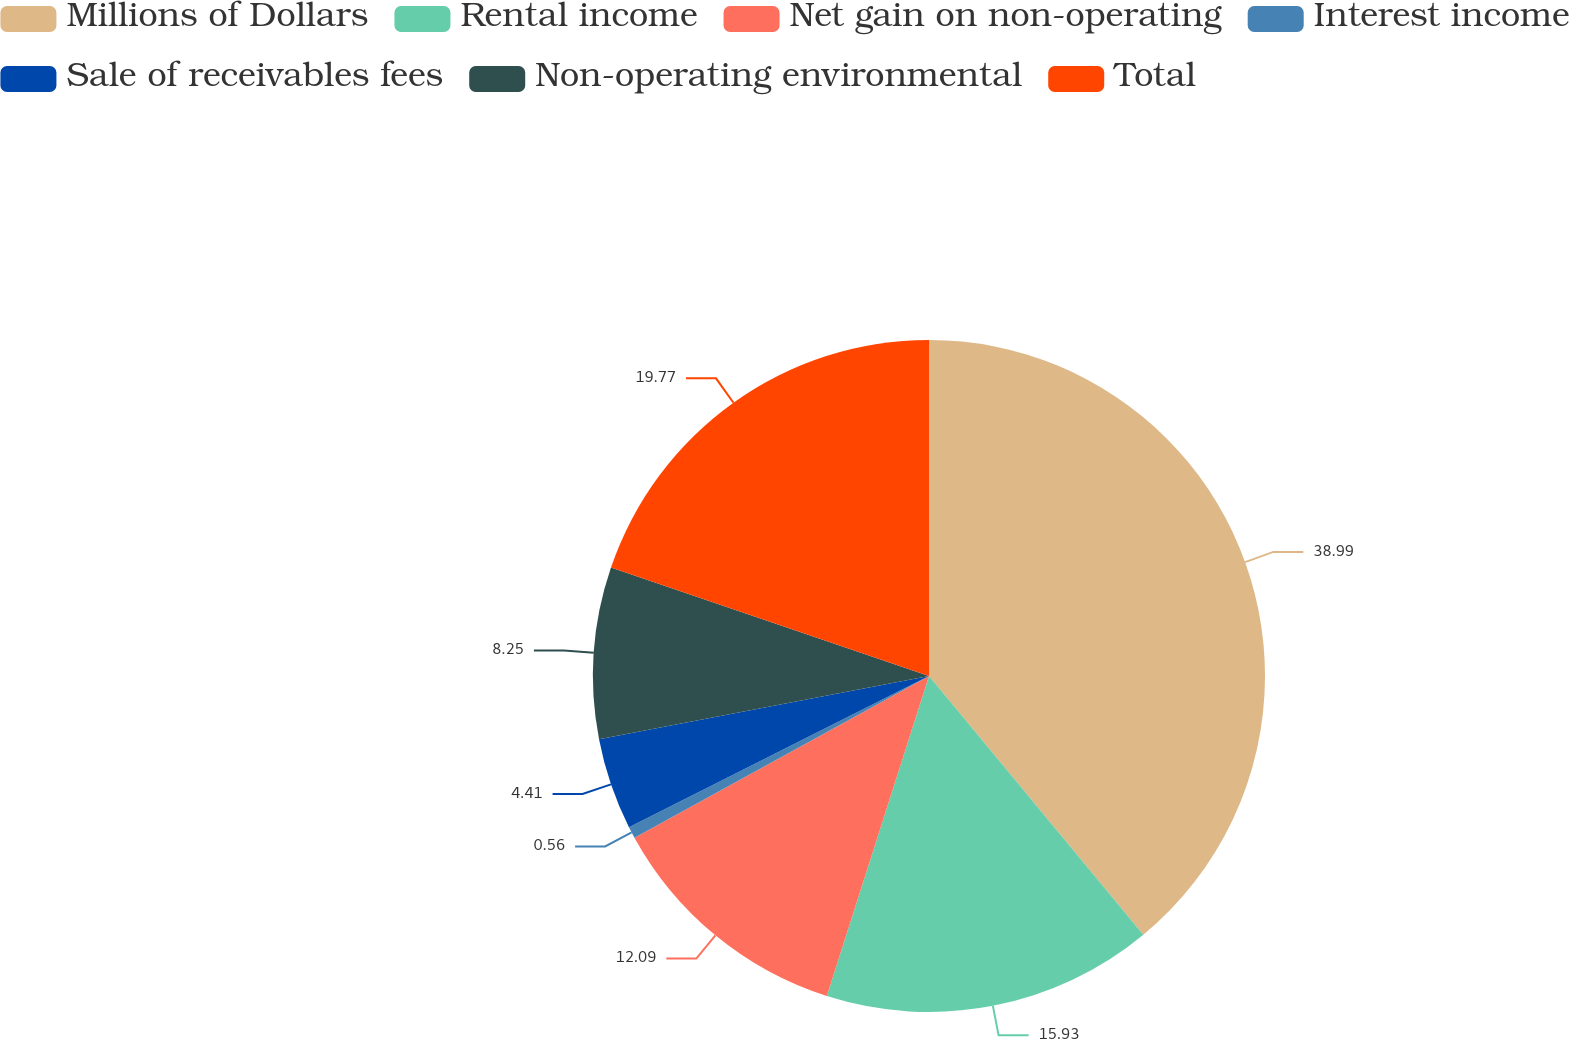<chart> <loc_0><loc_0><loc_500><loc_500><pie_chart><fcel>Millions of Dollars<fcel>Rental income<fcel>Net gain on non-operating<fcel>Interest income<fcel>Sale of receivables fees<fcel>Non-operating environmental<fcel>Total<nl><fcel>38.99%<fcel>15.93%<fcel>12.09%<fcel>0.56%<fcel>4.41%<fcel>8.25%<fcel>19.77%<nl></chart> 